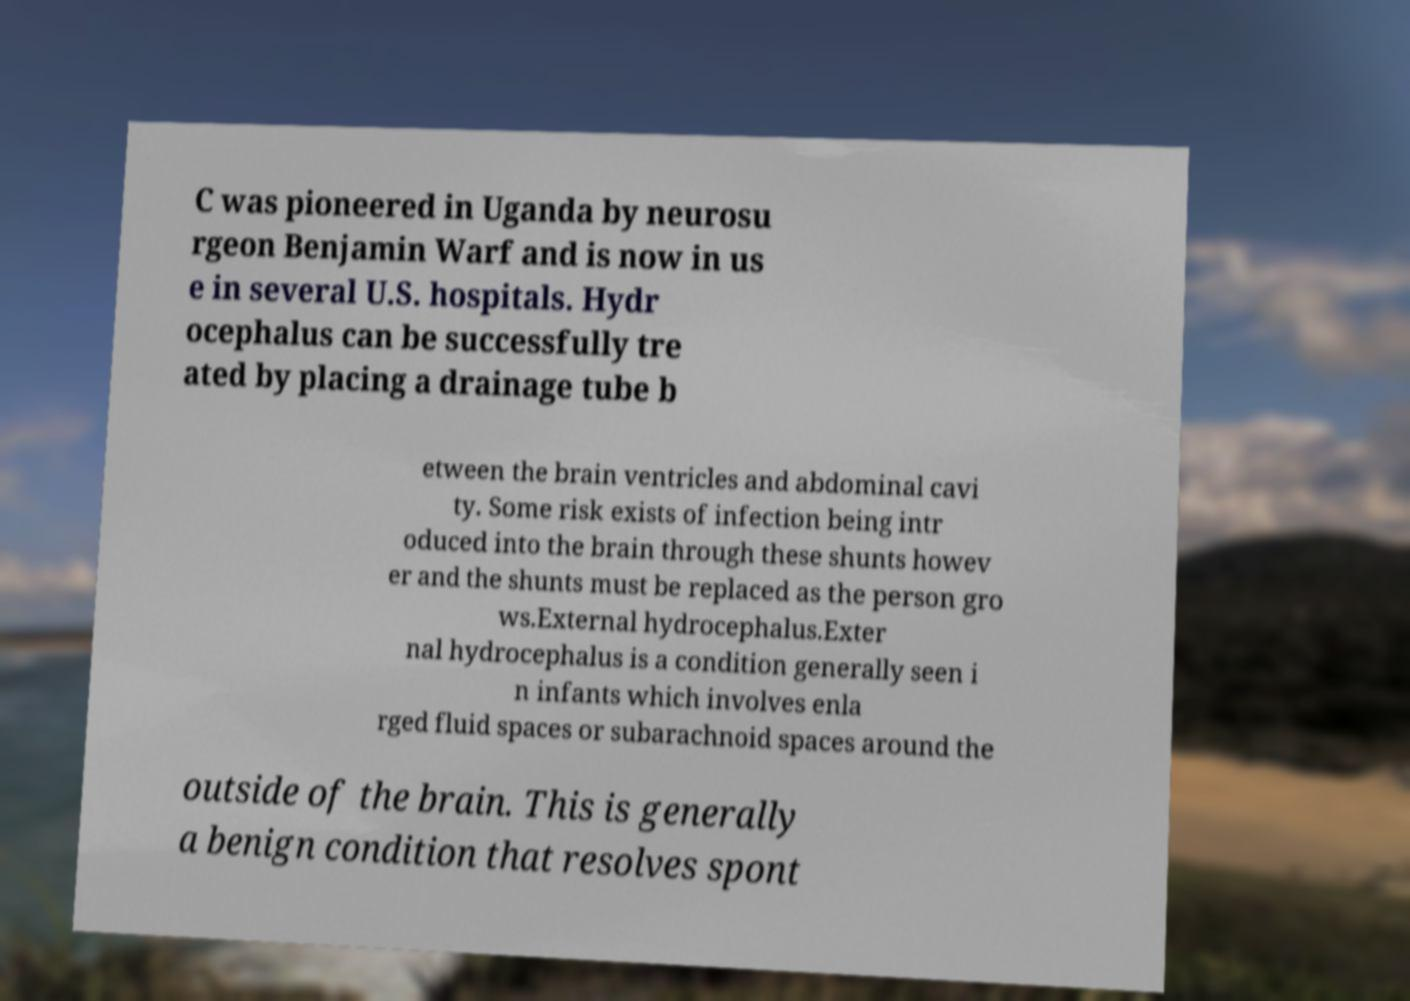Can you accurately transcribe the text from the provided image for me? C was pioneered in Uganda by neurosu rgeon Benjamin Warf and is now in us e in several U.S. hospitals. Hydr ocephalus can be successfully tre ated by placing a drainage tube b etween the brain ventricles and abdominal cavi ty. Some risk exists of infection being intr oduced into the brain through these shunts howev er and the shunts must be replaced as the person gro ws.External hydrocephalus.Exter nal hydrocephalus is a condition generally seen i n infants which involves enla rged fluid spaces or subarachnoid spaces around the outside of the brain. This is generally a benign condition that resolves spont 